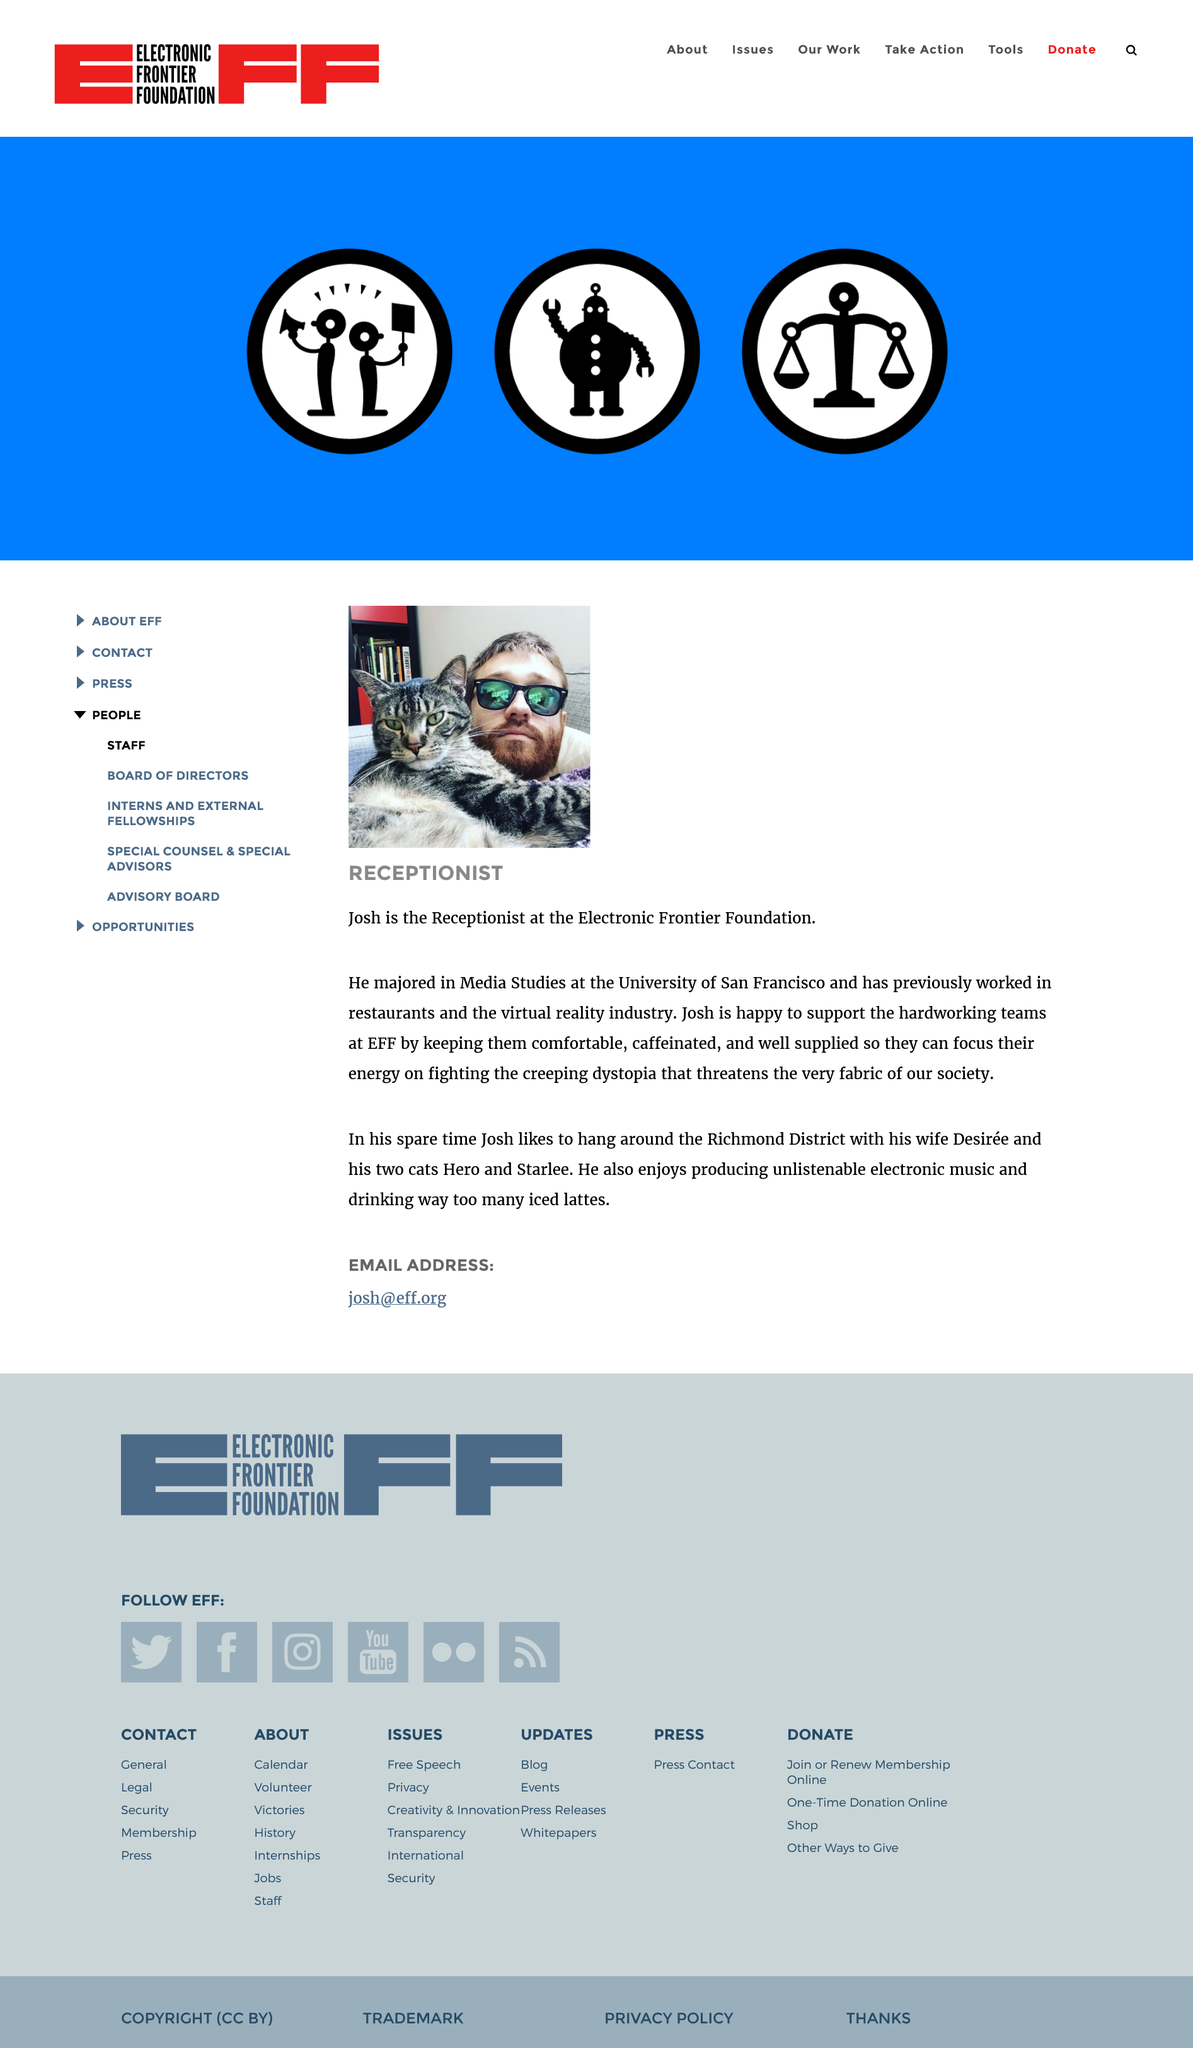Point out several critical features in this image. Josh attended the University of San Francisco. Josh is a receptionist who holds the job title of Josh. Josh works at the Electronic Frontier Foundation. 